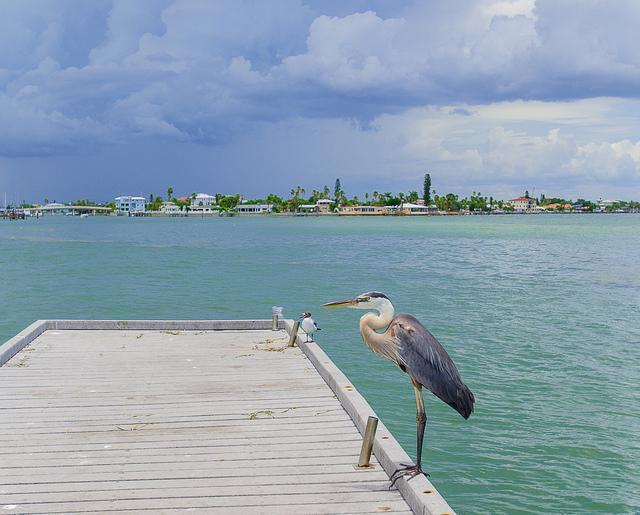How many birds are standing on the dock?
Give a very brief answer. 2. How many cars can be seen?
Give a very brief answer. 0. 